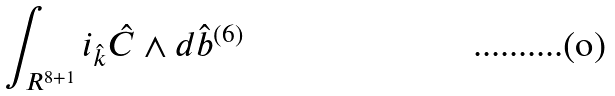<formula> <loc_0><loc_0><loc_500><loc_500>\int _ { R ^ { 8 + 1 } } i _ { \hat { k } } { \hat { C } } \wedge d { \hat { b } } ^ { ( 6 ) }</formula> 